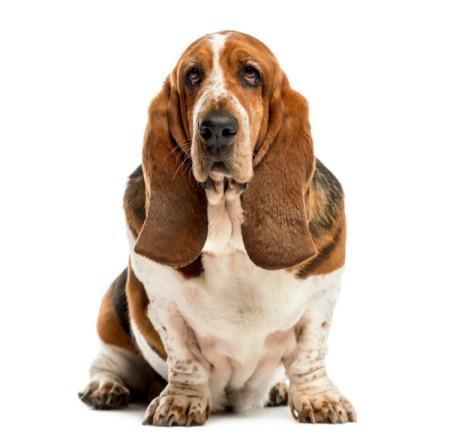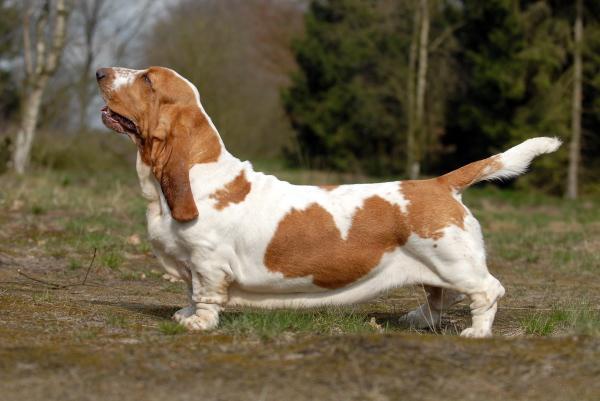The first image is the image on the left, the second image is the image on the right. For the images shown, is this caption "The dog in the image on the right is standing on the grass." true? Answer yes or no. Yes. The first image is the image on the left, the second image is the image on the right. Examine the images to the left and right. Is the description "One image shows a basset hound standing on all fours in profile, and the other image shows a basset hound viewed head on." accurate? Answer yes or no. Yes. 